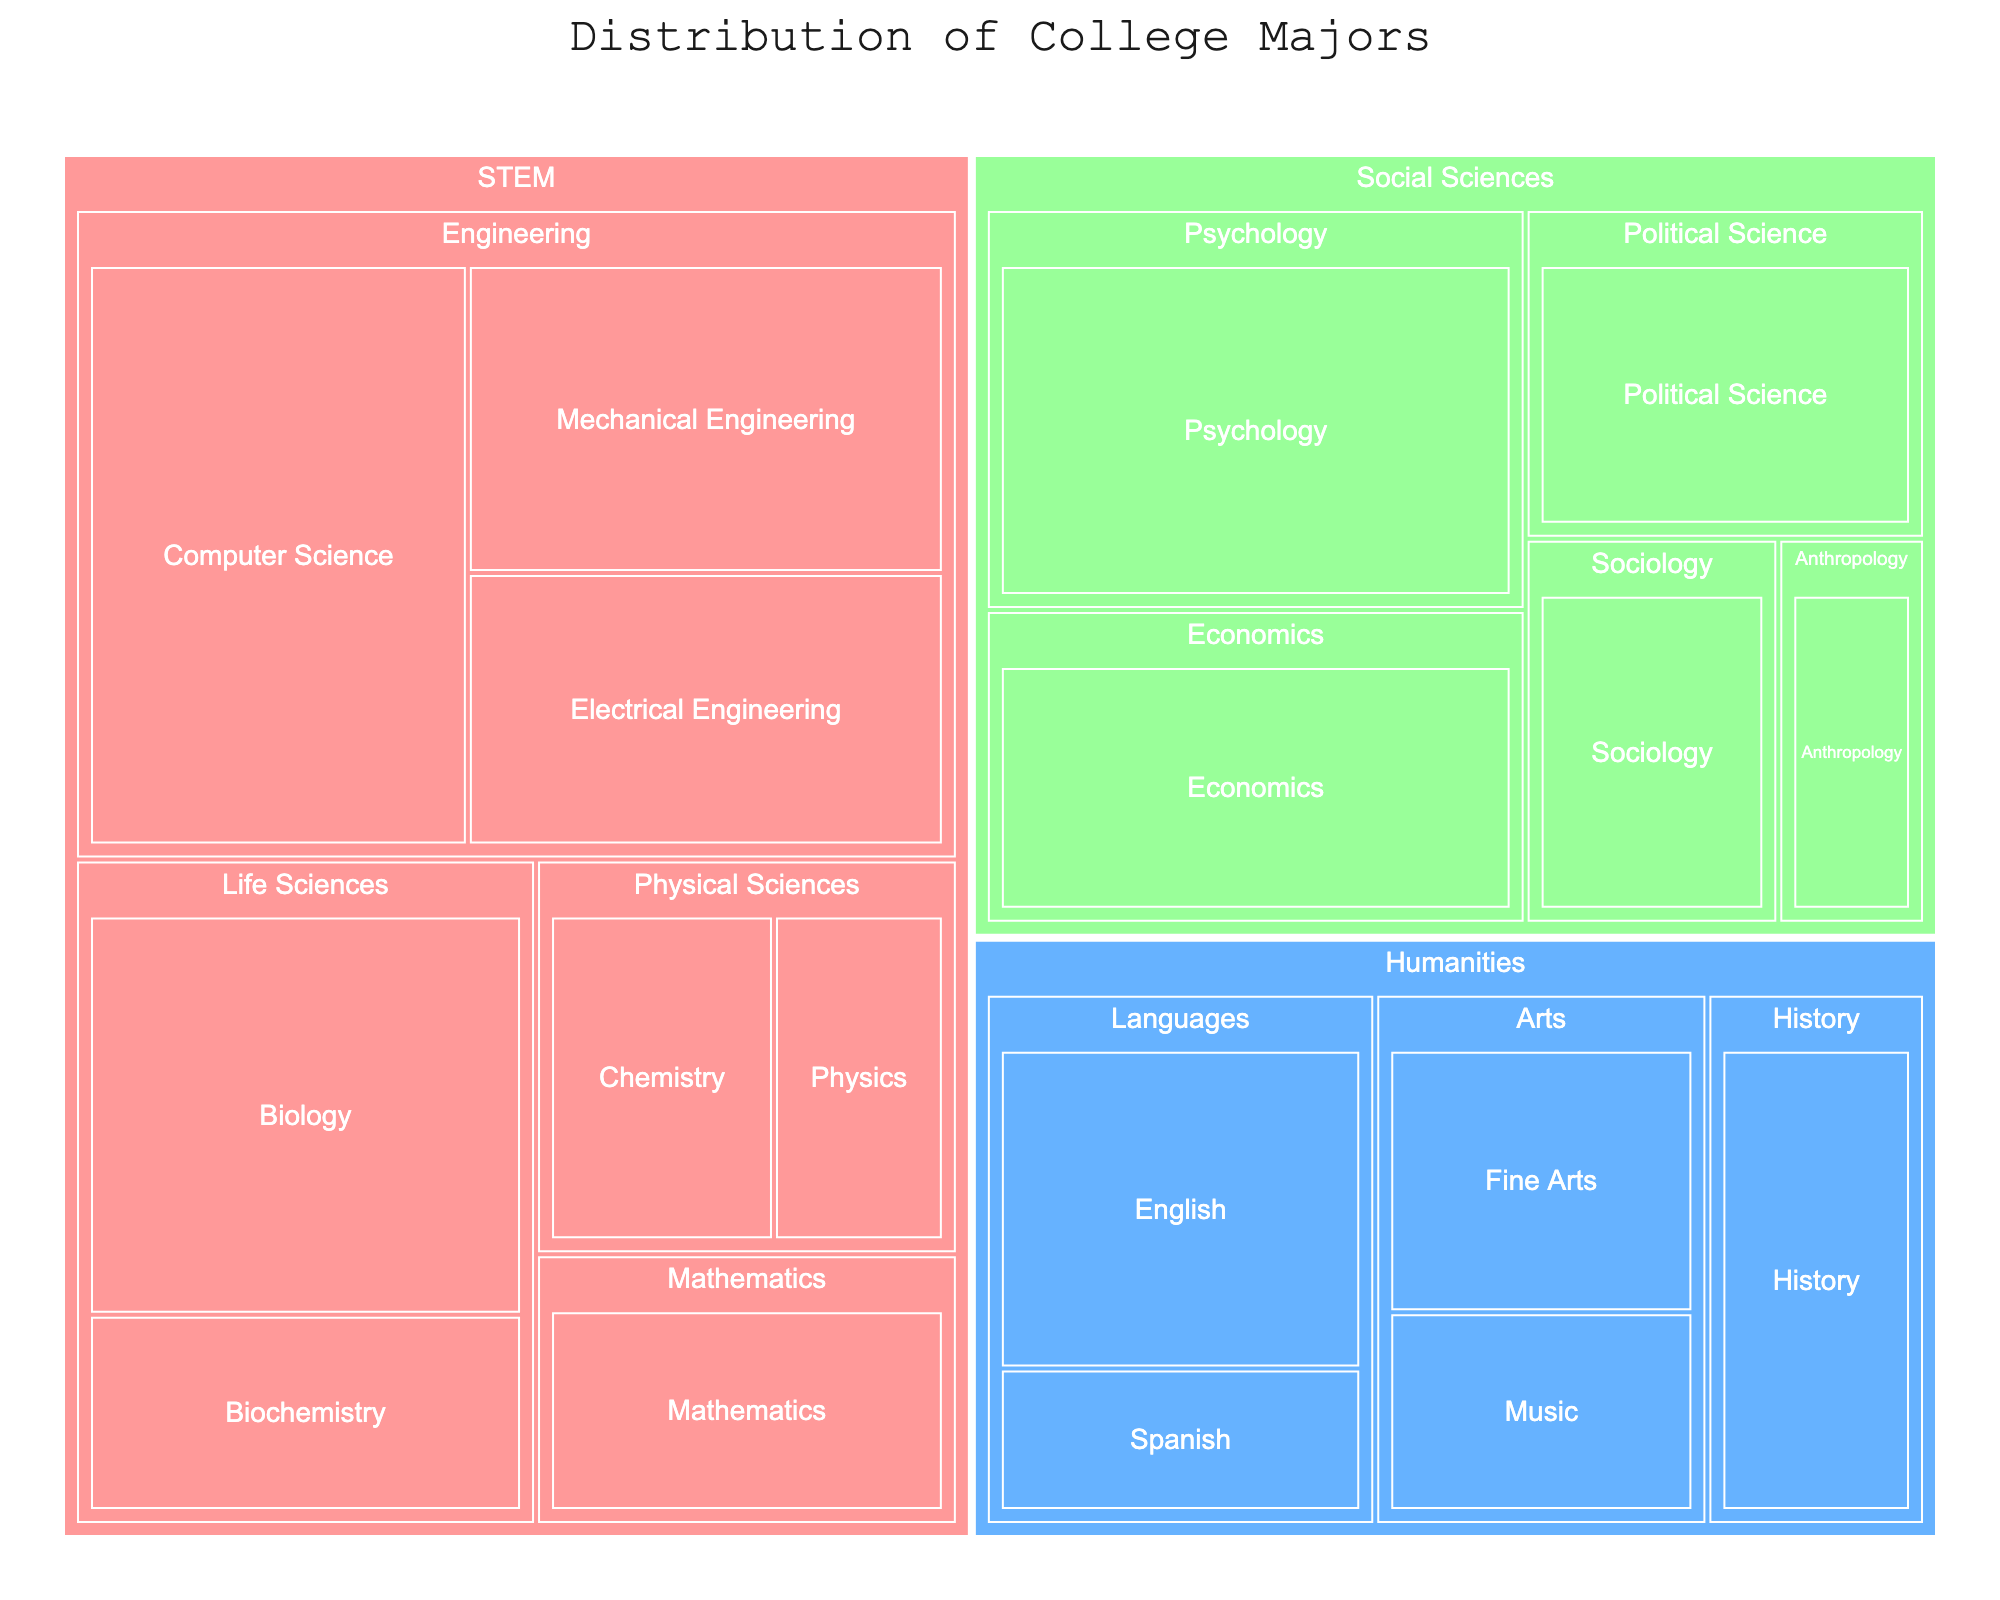What's the title of the figure? The title is typically displayed at the top of the Treemap. From the code provided, the title is set to 'Distribution of College Majors'.
Answer: Distribution of College Majors Which category has the highest percentage for a single major? To find the highest percentage, look at the largest segment within the Treemap. Computer Science, under STEM, has the highest percentage of 7.8%.
Answer: STEM What's the total percentage of majors under Humanities? Sum all the percentages under the Humanities category: English (4.7), Spanish (2.1), Fine Arts (3.3), Music (2.5), and History (3.8). Total: 4.7 + 2.1 + 3.3 + 2.5 + 3.8 = 16.4%.
Answer: 16.4% Which subcategory within Social Sciences has the lowest percentage? Look at the segments under Social Sciences. Anthropology has the lowest percentage at 1.8%.
Answer: Anthropology Compare the percentages of Mechanical Engineering and Economics. Which one has a higher value and by how much? Mechanical Engineering has 5.2% and Economics has 5.4%. Economics is higher. The difference is 5.4% - 5.2% = 0.2%.
Answer: Economics by 0.2% What is the percentage of majors in Life Sciences? Sum the percentages of Biology (6.3) and Biochemistry (3.1) under Life Sciences. Total: 6.3 + 3.1 = 9.4%.
Answer: 9.4% Which category is represented by the color blue in the Treemap? The Treemap's color scheme was provided in the code. Humanities is represented by the color blue (#66B2FF).
Answer: Humanities How does the percentage of Chemistry compare to Physics? Chemistry has a percentage of 2.9% and Physics has 2.2%. Chemistry is higher by 2.9% - 2.2% = 0.7%.
Answer: Chemistry by 0.7% What's the average percentage of majors in the Engineering subcategory? There are three majors in Engineering: Mechanical Engineering (5.2), Computer Science (7.8), and Electrical Engineering (4.6). Average: (5.2 + 7.8 + 4.6) / 3 = 5.87%.
Answer: 5.9% (rounded) How many majors are listed under STEM? Count all the majors listed under the STEM category. There are Mechanical Engineering, Computer Science, Electrical Engineering, Biology, Biochemistry, Chemistry, Physics, and Mathematics, giving a total of 8 majors.
Answer: 8 